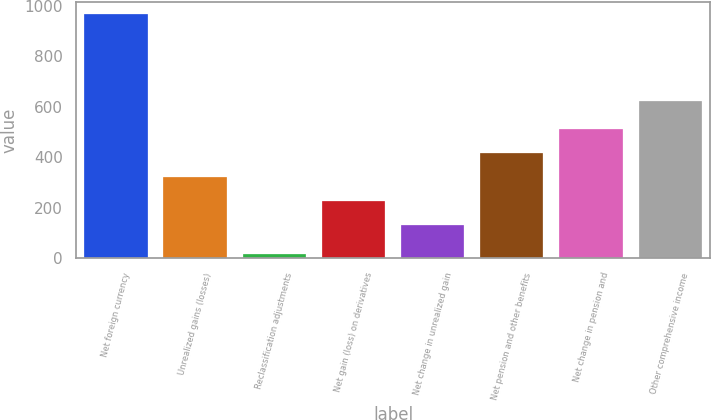Convert chart to OTSL. <chart><loc_0><loc_0><loc_500><loc_500><bar_chart><fcel>Net foreign currency<fcel>Unrealized gains (losses)<fcel>Reclassification adjustments<fcel>Net gain (loss) on derivatives<fcel>Net change in unrealized gain<fcel>Net pension and other benefits<fcel>Net change in pension and<fcel>Other comprehensive income<nl><fcel>966<fcel>322.8<fcel>17<fcel>227.9<fcel>133<fcel>417.7<fcel>512.6<fcel>623<nl></chart> 